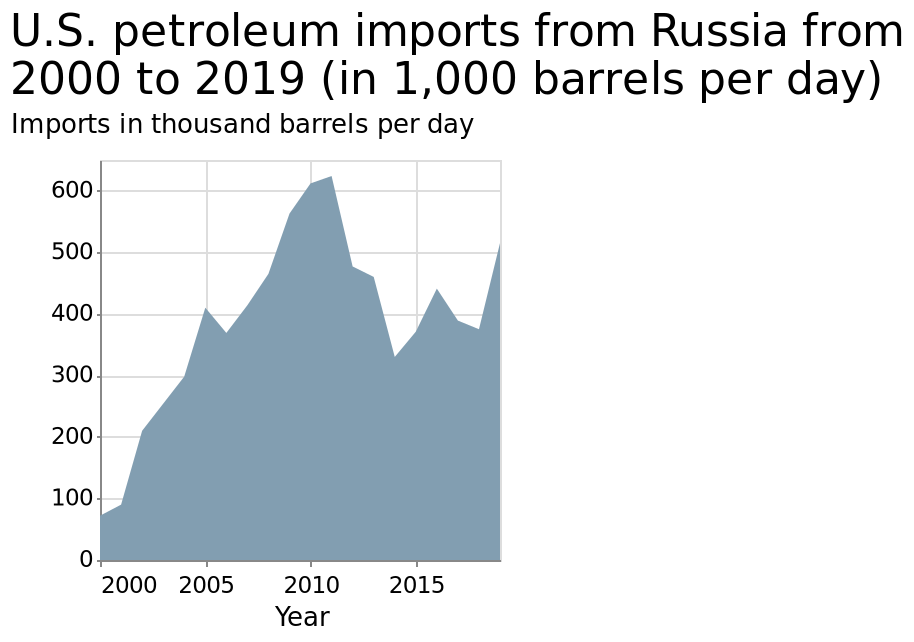<image>
Did the imports rise again after 2014? Yes, the imports rose again in 2015. 